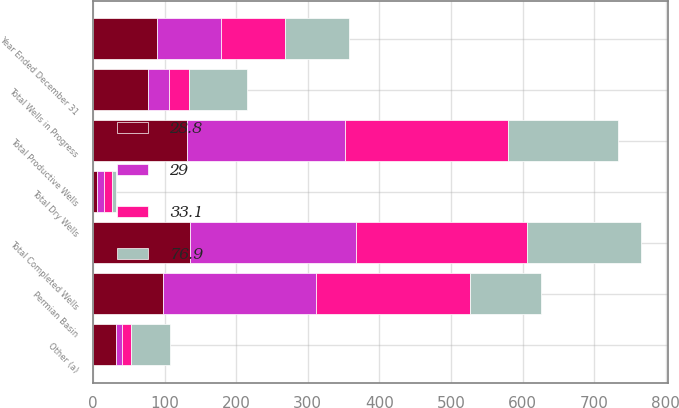Convert chart to OTSL. <chart><loc_0><loc_0><loc_500><loc_500><stacked_bar_chart><ecel><fcel>Year Ended December 31<fcel>Permian Basin<fcel>Other (a)<fcel>Total Productive Wells<fcel>Total Dry Wells<fcel>Total Completed Wells<fcel>Total Wells in Progress<nl><fcel>33.1<fcel>89.25<fcel>215<fcel>12<fcel>227<fcel>11<fcel>238<fcel>29<nl><fcel>29<fcel>89.25<fcel>212.5<fcel>8.8<fcel>221.3<fcel>11<fcel>232.3<fcel>28.8<nl><fcel>76.9<fcel>89.25<fcel>100<fcel>54<fcel>154<fcel>5<fcel>159<fcel>80<nl><fcel>28.8<fcel>89.25<fcel>98.5<fcel>32.2<fcel>130.7<fcel>5<fcel>135.7<fcel>76.9<nl></chart> 